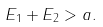Convert formula to latex. <formula><loc_0><loc_0><loc_500><loc_500>E _ { 1 } + E _ { 2 } > a .</formula> 